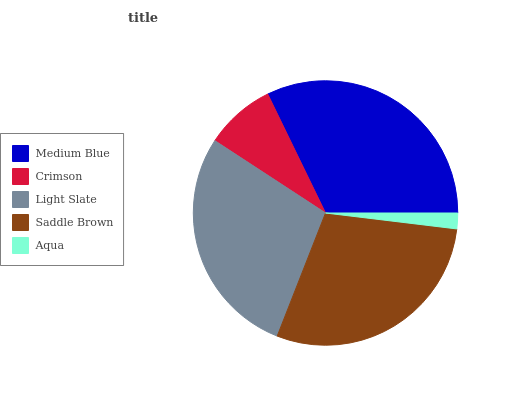Is Aqua the minimum?
Answer yes or no. Yes. Is Medium Blue the maximum?
Answer yes or no. Yes. Is Crimson the minimum?
Answer yes or no. No. Is Crimson the maximum?
Answer yes or no. No. Is Medium Blue greater than Crimson?
Answer yes or no. Yes. Is Crimson less than Medium Blue?
Answer yes or no. Yes. Is Crimson greater than Medium Blue?
Answer yes or no. No. Is Medium Blue less than Crimson?
Answer yes or no. No. Is Light Slate the high median?
Answer yes or no. Yes. Is Light Slate the low median?
Answer yes or no. Yes. Is Aqua the high median?
Answer yes or no. No. Is Saddle Brown the low median?
Answer yes or no. No. 